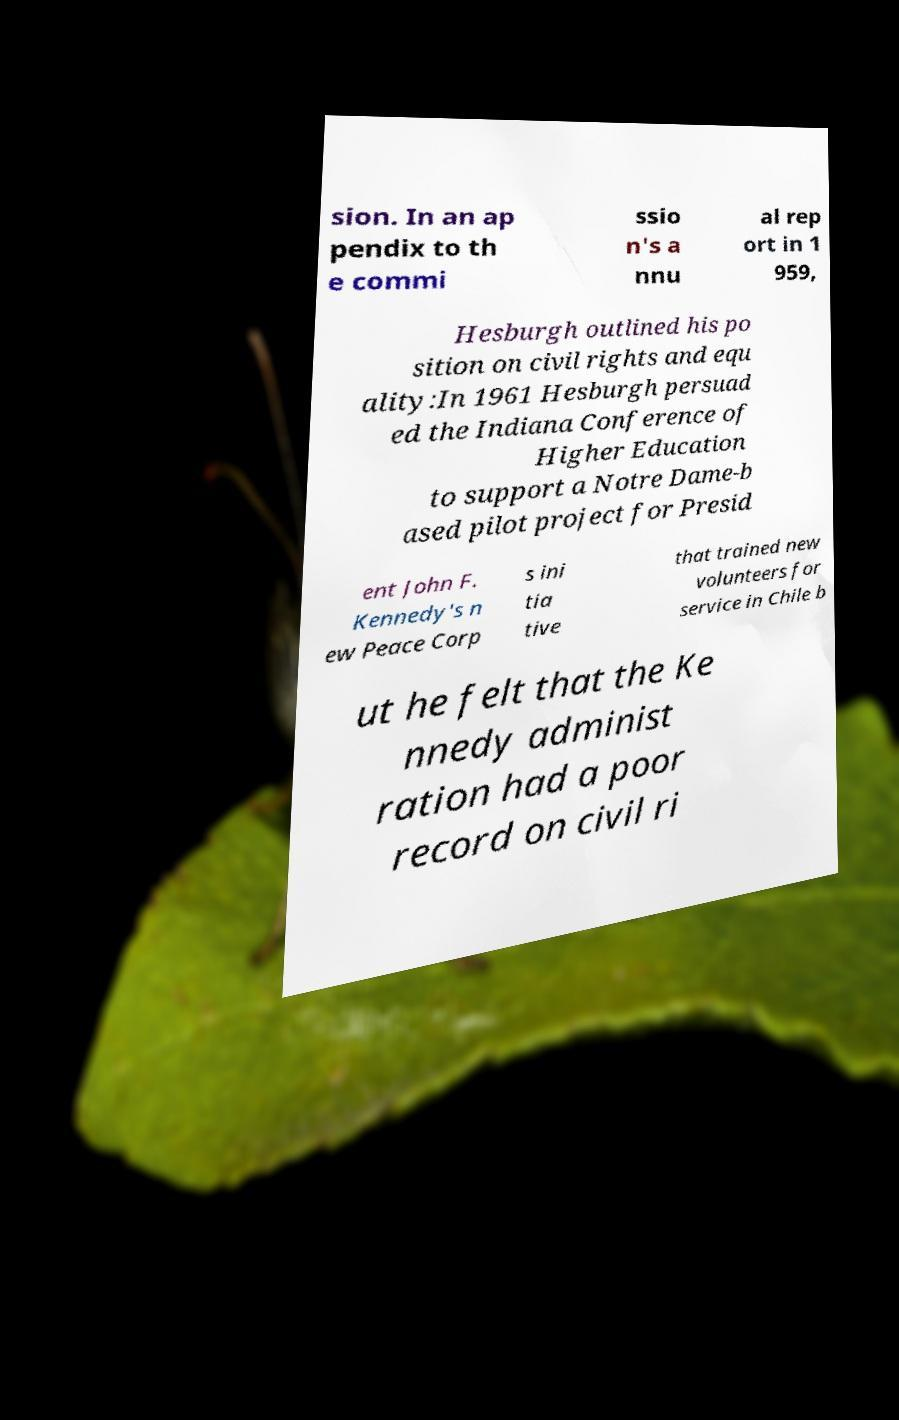Could you extract and type out the text from this image? sion. In an ap pendix to th e commi ssio n's a nnu al rep ort in 1 959, Hesburgh outlined his po sition on civil rights and equ ality:In 1961 Hesburgh persuad ed the Indiana Conference of Higher Education to support a Notre Dame-b ased pilot project for Presid ent John F. Kennedy's n ew Peace Corp s ini tia tive that trained new volunteers for service in Chile b ut he felt that the Ke nnedy administ ration had a poor record on civil ri 